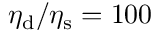Convert formula to latex. <formula><loc_0><loc_0><loc_500><loc_500>\eta _ { d } / \eta _ { s } = 1 0 0</formula> 